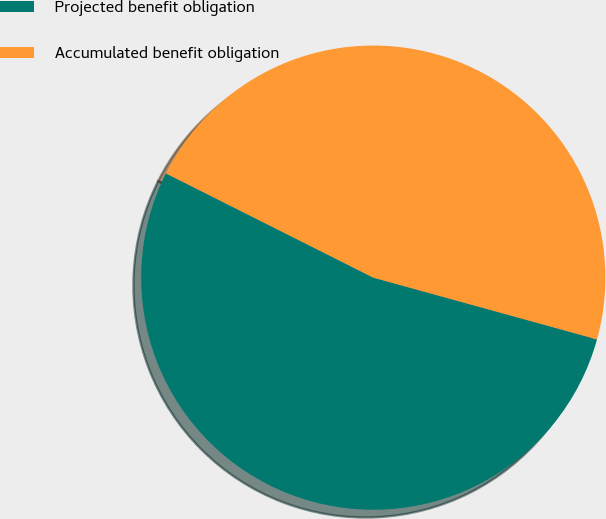Convert chart to OTSL. <chart><loc_0><loc_0><loc_500><loc_500><pie_chart><fcel>Projected benefit obligation<fcel>Accumulated benefit obligation<nl><fcel>53.13%<fcel>46.87%<nl></chart> 